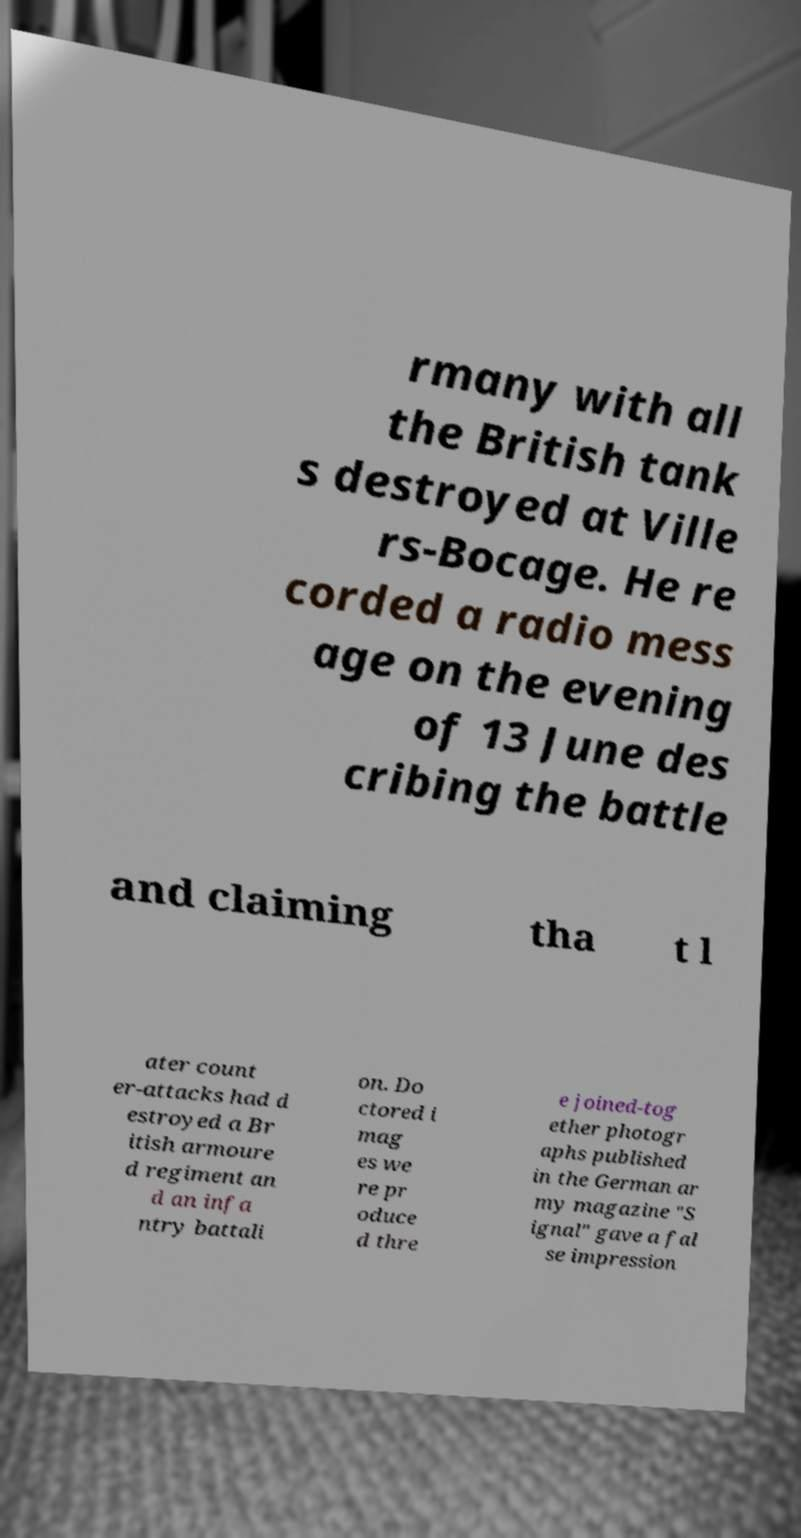There's text embedded in this image that I need extracted. Can you transcribe it verbatim? rmany with all the British tank s destroyed at Ville rs-Bocage. He re corded a radio mess age on the evening of 13 June des cribing the battle and claiming tha t l ater count er-attacks had d estroyed a Br itish armoure d regiment an d an infa ntry battali on. Do ctored i mag es we re pr oduce d thre e joined-tog ether photogr aphs published in the German ar my magazine "S ignal" gave a fal se impression 